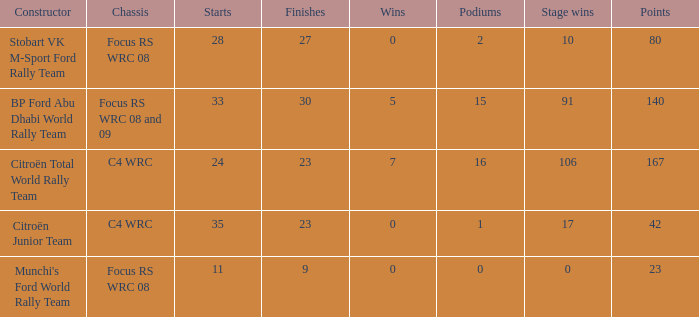What is the total number of points when the constructor is citroën total world rally team and the wins is less than 7? 0.0. 